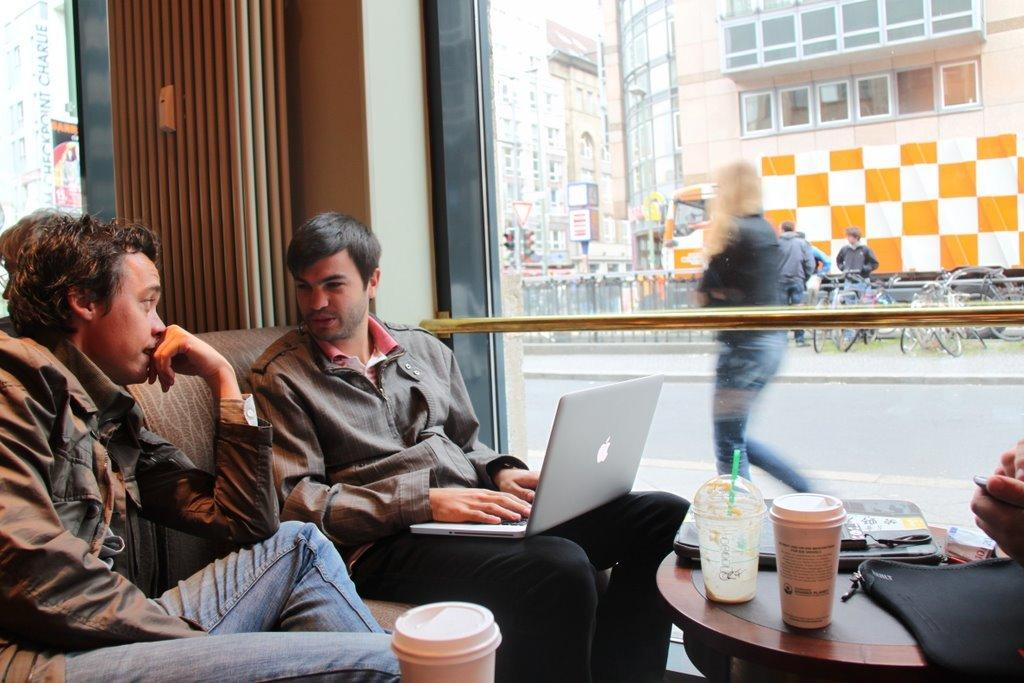How many people are in the image? There are two men in the image. What are the men doing in the image? The men are sitting on a sofa and talking to each other. What can be seen on the table in the image? There is a glass present on the table. What is visible through the window in the image? The facts provided do not mention what can be seen through the window. Where is the sofa located in the image? The sofa is likely in a room, as there is a window and a table present. What type of can is visible on the sofa in the image? There is no can present on the sofa or anywhere else in the image. 